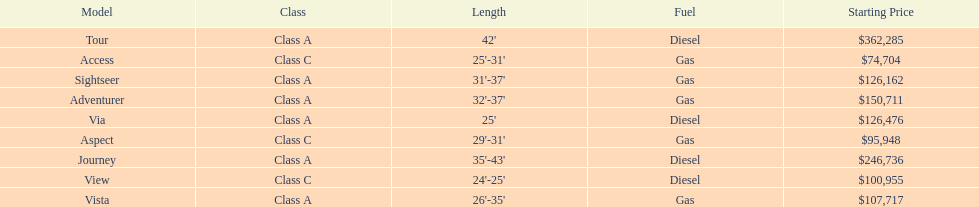Which model has the lowest starting price? Access. Which model has the second most highest starting price? Journey. Which model has the highest price in the winnebago industry? Tour. 